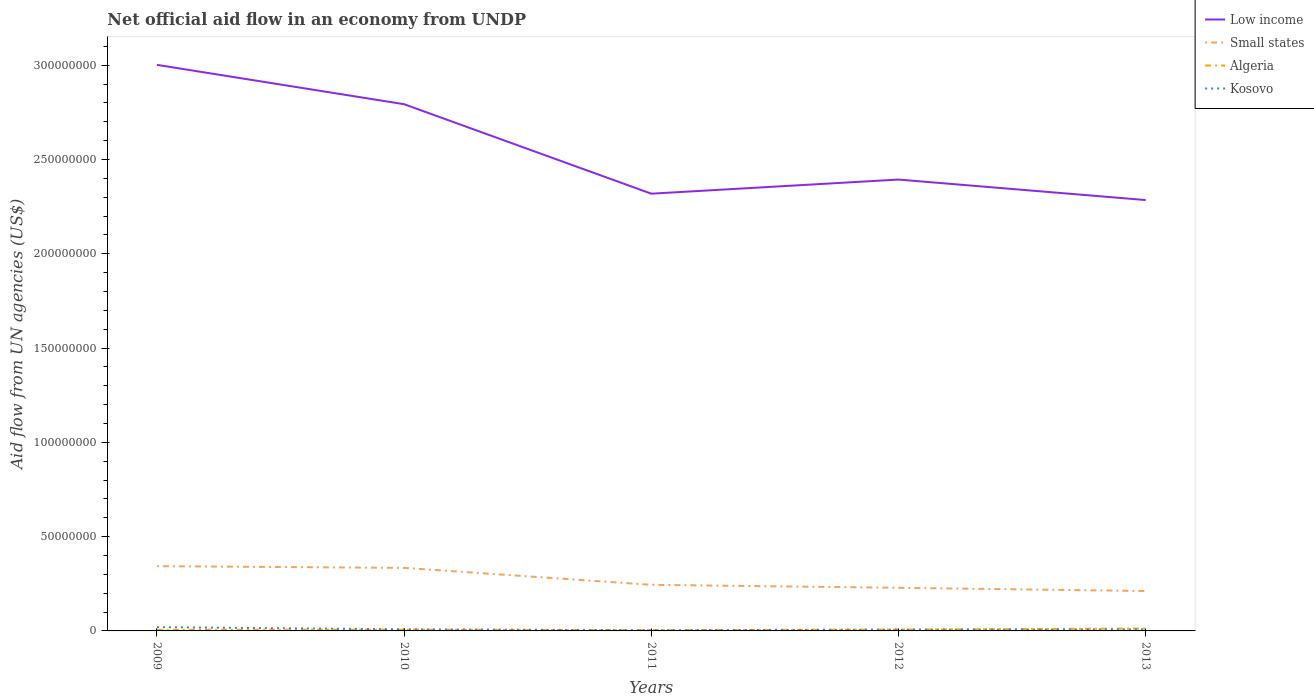Does the line corresponding to Kosovo intersect with the line corresponding to Algeria?
Provide a short and direct response. Yes. Across all years, what is the maximum net official aid flow in Algeria?
Your response must be concise. 4.20e+05. In which year was the net official aid flow in Kosovo maximum?
Offer a very short reply. 2011. What is the total net official aid flow in Algeria in the graph?
Your answer should be compact. -1.40e+05. What is the difference between the highest and the second highest net official aid flow in Algeria?
Provide a succinct answer. 8.40e+05. How many lines are there?
Your answer should be compact. 4. How many years are there in the graph?
Your answer should be compact. 5. Are the values on the major ticks of Y-axis written in scientific E-notation?
Your response must be concise. No. Does the graph contain grids?
Provide a short and direct response. No. How many legend labels are there?
Give a very brief answer. 4. How are the legend labels stacked?
Provide a short and direct response. Vertical. What is the title of the graph?
Your answer should be very brief. Net official aid flow in an economy from UNDP. Does "East Asia (developing only)" appear as one of the legend labels in the graph?
Provide a short and direct response. No. What is the label or title of the X-axis?
Ensure brevity in your answer.  Years. What is the label or title of the Y-axis?
Provide a short and direct response. Aid flow from UN agencies (US$). What is the Aid flow from UN agencies (US$) of Low income in 2009?
Offer a very short reply. 3.00e+08. What is the Aid flow from UN agencies (US$) in Small states in 2009?
Provide a succinct answer. 3.43e+07. What is the Aid flow from UN agencies (US$) of Algeria in 2009?
Give a very brief answer. 5.80e+05. What is the Aid flow from UN agencies (US$) of Kosovo in 2009?
Give a very brief answer. 1.99e+06. What is the Aid flow from UN agencies (US$) of Low income in 2010?
Provide a succinct answer. 2.79e+08. What is the Aid flow from UN agencies (US$) in Small states in 2010?
Keep it short and to the point. 3.34e+07. What is the Aid flow from UN agencies (US$) in Algeria in 2010?
Keep it short and to the point. 6.80e+05. What is the Aid flow from UN agencies (US$) in Kosovo in 2010?
Offer a terse response. 8.50e+05. What is the Aid flow from UN agencies (US$) in Low income in 2011?
Offer a very short reply. 2.32e+08. What is the Aid flow from UN agencies (US$) of Small states in 2011?
Your response must be concise. 2.44e+07. What is the Aid flow from UN agencies (US$) of Algeria in 2011?
Ensure brevity in your answer.  4.20e+05. What is the Aid flow from UN agencies (US$) in Kosovo in 2011?
Make the answer very short. 3.80e+05. What is the Aid flow from UN agencies (US$) in Low income in 2012?
Give a very brief answer. 2.39e+08. What is the Aid flow from UN agencies (US$) of Small states in 2012?
Offer a terse response. 2.29e+07. What is the Aid flow from UN agencies (US$) in Algeria in 2012?
Your answer should be very brief. 7.20e+05. What is the Aid flow from UN agencies (US$) in Kosovo in 2012?
Ensure brevity in your answer.  6.80e+05. What is the Aid flow from UN agencies (US$) in Low income in 2013?
Your response must be concise. 2.28e+08. What is the Aid flow from UN agencies (US$) of Small states in 2013?
Offer a terse response. 2.12e+07. What is the Aid flow from UN agencies (US$) of Algeria in 2013?
Your response must be concise. 1.26e+06. What is the Aid flow from UN agencies (US$) in Kosovo in 2013?
Offer a terse response. 8.30e+05. Across all years, what is the maximum Aid flow from UN agencies (US$) in Low income?
Your response must be concise. 3.00e+08. Across all years, what is the maximum Aid flow from UN agencies (US$) of Small states?
Provide a succinct answer. 3.43e+07. Across all years, what is the maximum Aid flow from UN agencies (US$) of Algeria?
Your response must be concise. 1.26e+06. Across all years, what is the maximum Aid flow from UN agencies (US$) in Kosovo?
Offer a very short reply. 1.99e+06. Across all years, what is the minimum Aid flow from UN agencies (US$) of Low income?
Provide a short and direct response. 2.28e+08. Across all years, what is the minimum Aid flow from UN agencies (US$) of Small states?
Your response must be concise. 2.12e+07. Across all years, what is the minimum Aid flow from UN agencies (US$) of Algeria?
Keep it short and to the point. 4.20e+05. What is the total Aid flow from UN agencies (US$) in Low income in the graph?
Provide a short and direct response. 1.28e+09. What is the total Aid flow from UN agencies (US$) of Small states in the graph?
Offer a terse response. 1.36e+08. What is the total Aid flow from UN agencies (US$) of Algeria in the graph?
Offer a very short reply. 3.66e+06. What is the total Aid flow from UN agencies (US$) in Kosovo in the graph?
Provide a succinct answer. 4.73e+06. What is the difference between the Aid flow from UN agencies (US$) in Low income in 2009 and that in 2010?
Give a very brief answer. 2.09e+07. What is the difference between the Aid flow from UN agencies (US$) in Small states in 2009 and that in 2010?
Provide a succinct answer. 9.10e+05. What is the difference between the Aid flow from UN agencies (US$) in Kosovo in 2009 and that in 2010?
Ensure brevity in your answer.  1.14e+06. What is the difference between the Aid flow from UN agencies (US$) in Low income in 2009 and that in 2011?
Provide a succinct answer. 6.83e+07. What is the difference between the Aid flow from UN agencies (US$) of Small states in 2009 and that in 2011?
Your answer should be very brief. 9.89e+06. What is the difference between the Aid flow from UN agencies (US$) in Kosovo in 2009 and that in 2011?
Give a very brief answer. 1.61e+06. What is the difference between the Aid flow from UN agencies (US$) in Low income in 2009 and that in 2012?
Make the answer very short. 6.08e+07. What is the difference between the Aid flow from UN agencies (US$) in Small states in 2009 and that in 2012?
Make the answer very short. 1.15e+07. What is the difference between the Aid flow from UN agencies (US$) of Algeria in 2009 and that in 2012?
Make the answer very short. -1.40e+05. What is the difference between the Aid flow from UN agencies (US$) of Kosovo in 2009 and that in 2012?
Ensure brevity in your answer.  1.31e+06. What is the difference between the Aid flow from UN agencies (US$) of Low income in 2009 and that in 2013?
Your answer should be compact. 7.17e+07. What is the difference between the Aid flow from UN agencies (US$) in Small states in 2009 and that in 2013?
Offer a very short reply. 1.32e+07. What is the difference between the Aid flow from UN agencies (US$) of Algeria in 2009 and that in 2013?
Offer a very short reply. -6.80e+05. What is the difference between the Aid flow from UN agencies (US$) of Kosovo in 2009 and that in 2013?
Provide a succinct answer. 1.16e+06. What is the difference between the Aid flow from UN agencies (US$) in Low income in 2010 and that in 2011?
Provide a short and direct response. 4.74e+07. What is the difference between the Aid flow from UN agencies (US$) in Small states in 2010 and that in 2011?
Provide a succinct answer. 8.98e+06. What is the difference between the Aid flow from UN agencies (US$) in Low income in 2010 and that in 2012?
Offer a terse response. 4.00e+07. What is the difference between the Aid flow from UN agencies (US$) of Small states in 2010 and that in 2012?
Give a very brief answer. 1.06e+07. What is the difference between the Aid flow from UN agencies (US$) of Kosovo in 2010 and that in 2012?
Keep it short and to the point. 1.70e+05. What is the difference between the Aid flow from UN agencies (US$) in Low income in 2010 and that in 2013?
Your response must be concise. 5.08e+07. What is the difference between the Aid flow from UN agencies (US$) of Small states in 2010 and that in 2013?
Offer a very short reply. 1.23e+07. What is the difference between the Aid flow from UN agencies (US$) in Algeria in 2010 and that in 2013?
Offer a very short reply. -5.80e+05. What is the difference between the Aid flow from UN agencies (US$) of Kosovo in 2010 and that in 2013?
Offer a terse response. 2.00e+04. What is the difference between the Aid flow from UN agencies (US$) of Low income in 2011 and that in 2012?
Keep it short and to the point. -7.49e+06. What is the difference between the Aid flow from UN agencies (US$) of Small states in 2011 and that in 2012?
Your response must be concise. 1.58e+06. What is the difference between the Aid flow from UN agencies (US$) in Low income in 2011 and that in 2013?
Give a very brief answer. 3.38e+06. What is the difference between the Aid flow from UN agencies (US$) in Small states in 2011 and that in 2013?
Provide a short and direct response. 3.29e+06. What is the difference between the Aid flow from UN agencies (US$) in Algeria in 2011 and that in 2013?
Keep it short and to the point. -8.40e+05. What is the difference between the Aid flow from UN agencies (US$) of Kosovo in 2011 and that in 2013?
Ensure brevity in your answer.  -4.50e+05. What is the difference between the Aid flow from UN agencies (US$) in Low income in 2012 and that in 2013?
Your answer should be compact. 1.09e+07. What is the difference between the Aid flow from UN agencies (US$) of Small states in 2012 and that in 2013?
Offer a very short reply. 1.71e+06. What is the difference between the Aid flow from UN agencies (US$) in Algeria in 2012 and that in 2013?
Your answer should be very brief. -5.40e+05. What is the difference between the Aid flow from UN agencies (US$) in Kosovo in 2012 and that in 2013?
Ensure brevity in your answer.  -1.50e+05. What is the difference between the Aid flow from UN agencies (US$) in Low income in 2009 and the Aid flow from UN agencies (US$) in Small states in 2010?
Offer a very short reply. 2.67e+08. What is the difference between the Aid flow from UN agencies (US$) in Low income in 2009 and the Aid flow from UN agencies (US$) in Algeria in 2010?
Provide a succinct answer. 3.00e+08. What is the difference between the Aid flow from UN agencies (US$) of Low income in 2009 and the Aid flow from UN agencies (US$) of Kosovo in 2010?
Your answer should be compact. 2.99e+08. What is the difference between the Aid flow from UN agencies (US$) of Small states in 2009 and the Aid flow from UN agencies (US$) of Algeria in 2010?
Give a very brief answer. 3.37e+07. What is the difference between the Aid flow from UN agencies (US$) of Small states in 2009 and the Aid flow from UN agencies (US$) of Kosovo in 2010?
Offer a terse response. 3.35e+07. What is the difference between the Aid flow from UN agencies (US$) of Low income in 2009 and the Aid flow from UN agencies (US$) of Small states in 2011?
Ensure brevity in your answer.  2.76e+08. What is the difference between the Aid flow from UN agencies (US$) in Low income in 2009 and the Aid flow from UN agencies (US$) in Algeria in 2011?
Offer a terse response. 3.00e+08. What is the difference between the Aid flow from UN agencies (US$) in Low income in 2009 and the Aid flow from UN agencies (US$) in Kosovo in 2011?
Ensure brevity in your answer.  3.00e+08. What is the difference between the Aid flow from UN agencies (US$) in Small states in 2009 and the Aid flow from UN agencies (US$) in Algeria in 2011?
Ensure brevity in your answer.  3.39e+07. What is the difference between the Aid flow from UN agencies (US$) of Small states in 2009 and the Aid flow from UN agencies (US$) of Kosovo in 2011?
Your response must be concise. 3.40e+07. What is the difference between the Aid flow from UN agencies (US$) of Low income in 2009 and the Aid flow from UN agencies (US$) of Small states in 2012?
Your answer should be very brief. 2.77e+08. What is the difference between the Aid flow from UN agencies (US$) of Low income in 2009 and the Aid flow from UN agencies (US$) of Algeria in 2012?
Keep it short and to the point. 2.99e+08. What is the difference between the Aid flow from UN agencies (US$) in Low income in 2009 and the Aid flow from UN agencies (US$) in Kosovo in 2012?
Offer a terse response. 3.00e+08. What is the difference between the Aid flow from UN agencies (US$) in Small states in 2009 and the Aid flow from UN agencies (US$) in Algeria in 2012?
Provide a succinct answer. 3.36e+07. What is the difference between the Aid flow from UN agencies (US$) of Small states in 2009 and the Aid flow from UN agencies (US$) of Kosovo in 2012?
Provide a short and direct response. 3.37e+07. What is the difference between the Aid flow from UN agencies (US$) in Algeria in 2009 and the Aid flow from UN agencies (US$) in Kosovo in 2012?
Offer a terse response. -1.00e+05. What is the difference between the Aid flow from UN agencies (US$) in Low income in 2009 and the Aid flow from UN agencies (US$) in Small states in 2013?
Offer a terse response. 2.79e+08. What is the difference between the Aid flow from UN agencies (US$) in Low income in 2009 and the Aid flow from UN agencies (US$) in Algeria in 2013?
Provide a short and direct response. 2.99e+08. What is the difference between the Aid flow from UN agencies (US$) in Low income in 2009 and the Aid flow from UN agencies (US$) in Kosovo in 2013?
Provide a short and direct response. 2.99e+08. What is the difference between the Aid flow from UN agencies (US$) of Small states in 2009 and the Aid flow from UN agencies (US$) of Algeria in 2013?
Ensure brevity in your answer.  3.31e+07. What is the difference between the Aid flow from UN agencies (US$) in Small states in 2009 and the Aid flow from UN agencies (US$) in Kosovo in 2013?
Provide a succinct answer. 3.35e+07. What is the difference between the Aid flow from UN agencies (US$) in Low income in 2010 and the Aid flow from UN agencies (US$) in Small states in 2011?
Keep it short and to the point. 2.55e+08. What is the difference between the Aid flow from UN agencies (US$) in Low income in 2010 and the Aid flow from UN agencies (US$) in Algeria in 2011?
Keep it short and to the point. 2.79e+08. What is the difference between the Aid flow from UN agencies (US$) of Low income in 2010 and the Aid flow from UN agencies (US$) of Kosovo in 2011?
Your response must be concise. 2.79e+08. What is the difference between the Aid flow from UN agencies (US$) of Small states in 2010 and the Aid flow from UN agencies (US$) of Algeria in 2011?
Give a very brief answer. 3.30e+07. What is the difference between the Aid flow from UN agencies (US$) of Small states in 2010 and the Aid flow from UN agencies (US$) of Kosovo in 2011?
Your response must be concise. 3.30e+07. What is the difference between the Aid flow from UN agencies (US$) of Low income in 2010 and the Aid flow from UN agencies (US$) of Small states in 2012?
Keep it short and to the point. 2.56e+08. What is the difference between the Aid flow from UN agencies (US$) of Low income in 2010 and the Aid flow from UN agencies (US$) of Algeria in 2012?
Provide a short and direct response. 2.79e+08. What is the difference between the Aid flow from UN agencies (US$) in Low income in 2010 and the Aid flow from UN agencies (US$) in Kosovo in 2012?
Keep it short and to the point. 2.79e+08. What is the difference between the Aid flow from UN agencies (US$) in Small states in 2010 and the Aid flow from UN agencies (US$) in Algeria in 2012?
Your response must be concise. 3.27e+07. What is the difference between the Aid flow from UN agencies (US$) in Small states in 2010 and the Aid flow from UN agencies (US$) in Kosovo in 2012?
Provide a short and direct response. 3.28e+07. What is the difference between the Aid flow from UN agencies (US$) in Low income in 2010 and the Aid flow from UN agencies (US$) in Small states in 2013?
Give a very brief answer. 2.58e+08. What is the difference between the Aid flow from UN agencies (US$) in Low income in 2010 and the Aid flow from UN agencies (US$) in Algeria in 2013?
Offer a terse response. 2.78e+08. What is the difference between the Aid flow from UN agencies (US$) of Low income in 2010 and the Aid flow from UN agencies (US$) of Kosovo in 2013?
Your answer should be very brief. 2.78e+08. What is the difference between the Aid flow from UN agencies (US$) in Small states in 2010 and the Aid flow from UN agencies (US$) in Algeria in 2013?
Your answer should be very brief. 3.22e+07. What is the difference between the Aid flow from UN agencies (US$) in Small states in 2010 and the Aid flow from UN agencies (US$) in Kosovo in 2013?
Offer a terse response. 3.26e+07. What is the difference between the Aid flow from UN agencies (US$) of Low income in 2011 and the Aid flow from UN agencies (US$) of Small states in 2012?
Give a very brief answer. 2.09e+08. What is the difference between the Aid flow from UN agencies (US$) of Low income in 2011 and the Aid flow from UN agencies (US$) of Algeria in 2012?
Provide a short and direct response. 2.31e+08. What is the difference between the Aid flow from UN agencies (US$) of Low income in 2011 and the Aid flow from UN agencies (US$) of Kosovo in 2012?
Ensure brevity in your answer.  2.31e+08. What is the difference between the Aid flow from UN agencies (US$) in Small states in 2011 and the Aid flow from UN agencies (US$) in Algeria in 2012?
Give a very brief answer. 2.37e+07. What is the difference between the Aid flow from UN agencies (US$) of Small states in 2011 and the Aid flow from UN agencies (US$) of Kosovo in 2012?
Offer a terse response. 2.38e+07. What is the difference between the Aid flow from UN agencies (US$) in Low income in 2011 and the Aid flow from UN agencies (US$) in Small states in 2013?
Your response must be concise. 2.11e+08. What is the difference between the Aid flow from UN agencies (US$) in Low income in 2011 and the Aid flow from UN agencies (US$) in Algeria in 2013?
Your answer should be very brief. 2.31e+08. What is the difference between the Aid flow from UN agencies (US$) of Low income in 2011 and the Aid flow from UN agencies (US$) of Kosovo in 2013?
Offer a terse response. 2.31e+08. What is the difference between the Aid flow from UN agencies (US$) in Small states in 2011 and the Aid flow from UN agencies (US$) in Algeria in 2013?
Your answer should be compact. 2.32e+07. What is the difference between the Aid flow from UN agencies (US$) of Small states in 2011 and the Aid flow from UN agencies (US$) of Kosovo in 2013?
Offer a very short reply. 2.36e+07. What is the difference between the Aid flow from UN agencies (US$) in Algeria in 2011 and the Aid flow from UN agencies (US$) in Kosovo in 2013?
Your response must be concise. -4.10e+05. What is the difference between the Aid flow from UN agencies (US$) in Low income in 2012 and the Aid flow from UN agencies (US$) in Small states in 2013?
Give a very brief answer. 2.18e+08. What is the difference between the Aid flow from UN agencies (US$) of Low income in 2012 and the Aid flow from UN agencies (US$) of Algeria in 2013?
Your answer should be very brief. 2.38e+08. What is the difference between the Aid flow from UN agencies (US$) of Low income in 2012 and the Aid flow from UN agencies (US$) of Kosovo in 2013?
Provide a succinct answer. 2.39e+08. What is the difference between the Aid flow from UN agencies (US$) in Small states in 2012 and the Aid flow from UN agencies (US$) in Algeria in 2013?
Offer a very short reply. 2.16e+07. What is the difference between the Aid flow from UN agencies (US$) in Small states in 2012 and the Aid flow from UN agencies (US$) in Kosovo in 2013?
Offer a terse response. 2.20e+07. What is the difference between the Aid flow from UN agencies (US$) in Algeria in 2012 and the Aid flow from UN agencies (US$) in Kosovo in 2013?
Ensure brevity in your answer.  -1.10e+05. What is the average Aid flow from UN agencies (US$) in Low income per year?
Give a very brief answer. 2.56e+08. What is the average Aid flow from UN agencies (US$) in Small states per year?
Your answer should be very brief. 2.72e+07. What is the average Aid flow from UN agencies (US$) in Algeria per year?
Provide a short and direct response. 7.32e+05. What is the average Aid flow from UN agencies (US$) of Kosovo per year?
Provide a succinct answer. 9.46e+05. In the year 2009, what is the difference between the Aid flow from UN agencies (US$) of Low income and Aid flow from UN agencies (US$) of Small states?
Keep it short and to the point. 2.66e+08. In the year 2009, what is the difference between the Aid flow from UN agencies (US$) in Low income and Aid flow from UN agencies (US$) in Algeria?
Your answer should be very brief. 3.00e+08. In the year 2009, what is the difference between the Aid flow from UN agencies (US$) in Low income and Aid flow from UN agencies (US$) in Kosovo?
Give a very brief answer. 2.98e+08. In the year 2009, what is the difference between the Aid flow from UN agencies (US$) in Small states and Aid flow from UN agencies (US$) in Algeria?
Give a very brief answer. 3.38e+07. In the year 2009, what is the difference between the Aid flow from UN agencies (US$) in Small states and Aid flow from UN agencies (US$) in Kosovo?
Offer a very short reply. 3.24e+07. In the year 2009, what is the difference between the Aid flow from UN agencies (US$) in Algeria and Aid flow from UN agencies (US$) in Kosovo?
Provide a short and direct response. -1.41e+06. In the year 2010, what is the difference between the Aid flow from UN agencies (US$) in Low income and Aid flow from UN agencies (US$) in Small states?
Your answer should be very brief. 2.46e+08. In the year 2010, what is the difference between the Aid flow from UN agencies (US$) in Low income and Aid flow from UN agencies (US$) in Algeria?
Keep it short and to the point. 2.79e+08. In the year 2010, what is the difference between the Aid flow from UN agencies (US$) of Low income and Aid flow from UN agencies (US$) of Kosovo?
Provide a succinct answer. 2.78e+08. In the year 2010, what is the difference between the Aid flow from UN agencies (US$) in Small states and Aid flow from UN agencies (US$) in Algeria?
Offer a very short reply. 3.28e+07. In the year 2010, what is the difference between the Aid flow from UN agencies (US$) in Small states and Aid flow from UN agencies (US$) in Kosovo?
Give a very brief answer. 3.26e+07. In the year 2010, what is the difference between the Aid flow from UN agencies (US$) of Algeria and Aid flow from UN agencies (US$) of Kosovo?
Ensure brevity in your answer.  -1.70e+05. In the year 2011, what is the difference between the Aid flow from UN agencies (US$) of Low income and Aid flow from UN agencies (US$) of Small states?
Offer a very short reply. 2.07e+08. In the year 2011, what is the difference between the Aid flow from UN agencies (US$) in Low income and Aid flow from UN agencies (US$) in Algeria?
Provide a succinct answer. 2.31e+08. In the year 2011, what is the difference between the Aid flow from UN agencies (US$) of Low income and Aid flow from UN agencies (US$) of Kosovo?
Keep it short and to the point. 2.31e+08. In the year 2011, what is the difference between the Aid flow from UN agencies (US$) in Small states and Aid flow from UN agencies (US$) in Algeria?
Make the answer very short. 2.40e+07. In the year 2011, what is the difference between the Aid flow from UN agencies (US$) in Small states and Aid flow from UN agencies (US$) in Kosovo?
Provide a short and direct response. 2.41e+07. In the year 2011, what is the difference between the Aid flow from UN agencies (US$) in Algeria and Aid flow from UN agencies (US$) in Kosovo?
Keep it short and to the point. 4.00e+04. In the year 2012, what is the difference between the Aid flow from UN agencies (US$) in Low income and Aid flow from UN agencies (US$) in Small states?
Keep it short and to the point. 2.16e+08. In the year 2012, what is the difference between the Aid flow from UN agencies (US$) in Low income and Aid flow from UN agencies (US$) in Algeria?
Provide a succinct answer. 2.39e+08. In the year 2012, what is the difference between the Aid flow from UN agencies (US$) in Low income and Aid flow from UN agencies (US$) in Kosovo?
Provide a succinct answer. 2.39e+08. In the year 2012, what is the difference between the Aid flow from UN agencies (US$) of Small states and Aid flow from UN agencies (US$) of Algeria?
Offer a very short reply. 2.22e+07. In the year 2012, what is the difference between the Aid flow from UN agencies (US$) in Small states and Aid flow from UN agencies (US$) in Kosovo?
Your response must be concise. 2.22e+07. In the year 2013, what is the difference between the Aid flow from UN agencies (US$) in Low income and Aid flow from UN agencies (US$) in Small states?
Offer a very short reply. 2.07e+08. In the year 2013, what is the difference between the Aid flow from UN agencies (US$) of Low income and Aid flow from UN agencies (US$) of Algeria?
Keep it short and to the point. 2.27e+08. In the year 2013, what is the difference between the Aid flow from UN agencies (US$) of Low income and Aid flow from UN agencies (US$) of Kosovo?
Your response must be concise. 2.28e+08. In the year 2013, what is the difference between the Aid flow from UN agencies (US$) of Small states and Aid flow from UN agencies (US$) of Algeria?
Ensure brevity in your answer.  1.99e+07. In the year 2013, what is the difference between the Aid flow from UN agencies (US$) in Small states and Aid flow from UN agencies (US$) in Kosovo?
Provide a short and direct response. 2.03e+07. What is the ratio of the Aid flow from UN agencies (US$) in Low income in 2009 to that in 2010?
Offer a very short reply. 1.07. What is the ratio of the Aid flow from UN agencies (US$) of Small states in 2009 to that in 2010?
Offer a terse response. 1.03. What is the ratio of the Aid flow from UN agencies (US$) in Algeria in 2009 to that in 2010?
Offer a terse response. 0.85. What is the ratio of the Aid flow from UN agencies (US$) of Kosovo in 2009 to that in 2010?
Keep it short and to the point. 2.34. What is the ratio of the Aid flow from UN agencies (US$) of Low income in 2009 to that in 2011?
Keep it short and to the point. 1.29. What is the ratio of the Aid flow from UN agencies (US$) in Small states in 2009 to that in 2011?
Make the answer very short. 1.4. What is the ratio of the Aid flow from UN agencies (US$) in Algeria in 2009 to that in 2011?
Your answer should be compact. 1.38. What is the ratio of the Aid flow from UN agencies (US$) of Kosovo in 2009 to that in 2011?
Offer a terse response. 5.24. What is the ratio of the Aid flow from UN agencies (US$) of Low income in 2009 to that in 2012?
Ensure brevity in your answer.  1.25. What is the ratio of the Aid flow from UN agencies (US$) of Small states in 2009 to that in 2012?
Your response must be concise. 1.5. What is the ratio of the Aid flow from UN agencies (US$) in Algeria in 2009 to that in 2012?
Keep it short and to the point. 0.81. What is the ratio of the Aid flow from UN agencies (US$) of Kosovo in 2009 to that in 2012?
Offer a very short reply. 2.93. What is the ratio of the Aid flow from UN agencies (US$) in Low income in 2009 to that in 2013?
Keep it short and to the point. 1.31. What is the ratio of the Aid flow from UN agencies (US$) of Small states in 2009 to that in 2013?
Provide a short and direct response. 1.62. What is the ratio of the Aid flow from UN agencies (US$) of Algeria in 2009 to that in 2013?
Keep it short and to the point. 0.46. What is the ratio of the Aid flow from UN agencies (US$) of Kosovo in 2009 to that in 2013?
Make the answer very short. 2.4. What is the ratio of the Aid flow from UN agencies (US$) in Low income in 2010 to that in 2011?
Offer a very short reply. 1.2. What is the ratio of the Aid flow from UN agencies (US$) in Small states in 2010 to that in 2011?
Make the answer very short. 1.37. What is the ratio of the Aid flow from UN agencies (US$) of Algeria in 2010 to that in 2011?
Your answer should be very brief. 1.62. What is the ratio of the Aid flow from UN agencies (US$) in Kosovo in 2010 to that in 2011?
Ensure brevity in your answer.  2.24. What is the ratio of the Aid flow from UN agencies (US$) in Low income in 2010 to that in 2012?
Provide a succinct answer. 1.17. What is the ratio of the Aid flow from UN agencies (US$) in Small states in 2010 to that in 2012?
Ensure brevity in your answer.  1.46. What is the ratio of the Aid flow from UN agencies (US$) in Low income in 2010 to that in 2013?
Your answer should be very brief. 1.22. What is the ratio of the Aid flow from UN agencies (US$) in Small states in 2010 to that in 2013?
Offer a very short reply. 1.58. What is the ratio of the Aid flow from UN agencies (US$) of Algeria in 2010 to that in 2013?
Ensure brevity in your answer.  0.54. What is the ratio of the Aid flow from UN agencies (US$) of Kosovo in 2010 to that in 2013?
Provide a short and direct response. 1.02. What is the ratio of the Aid flow from UN agencies (US$) in Low income in 2011 to that in 2012?
Offer a very short reply. 0.97. What is the ratio of the Aid flow from UN agencies (US$) of Small states in 2011 to that in 2012?
Provide a succinct answer. 1.07. What is the ratio of the Aid flow from UN agencies (US$) in Algeria in 2011 to that in 2012?
Offer a terse response. 0.58. What is the ratio of the Aid flow from UN agencies (US$) in Kosovo in 2011 to that in 2012?
Offer a very short reply. 0.56. What is the ratio of the Aid flow from UN agencies (US$) in Low income in 2011 to that in 2013?
Offer a terse response. 1.01. What is the ratio of the Aid flow from UN agencies (US$) of Small states in 2011 to that in 2013?
Your response must be concise. 1.16. What is the ratio of the Aid flow from UN agencies (US$) of Algeria in 2011 to that in 2013?
Offer a very short reply. 0.33. What is the ratio of the Aid flow from UN agencies (US$) in Kosovo in 2011 to that in 2013?
Ensure brevity in your answer.  0.46. What is the ratio of the Aid flow from UN agencies (US$) in Low income in 2012 to that in 2013?
Ensure brevity in your answer.  1.05. What is the ratio of the Aid flow from UN agencies (US$) of Small states in 2012 to that in 2013?
Provide a succinct answer. 1.08. What is the ratio of the Aid flow from UN agencies (US$) in Kosovo in 2012 to that in 2013?
Give a very brief answer. 0.82. What is the difference between the highest and the second highest Aid flow from UN agencies (US$) in Low income?
Provide a short and direct response. 2.09e+07. What is the difference between the highest and the second highest Aid flow from UN agencies (US$) of Small states?
Keep it short and to the point. 9.10e+05. What is the difference between the highest and the second highest Aid flow from UN agencies (US$) of Algeria?
Your answer should be very brief. 5.40e+05. What is the difference between the highest and the second highest Aid flow from UN agencies (US$) in Kosovo?
Make the answer very short. 1.14e+06. What is the difference between the highest and the lowest Aid flow from UN agencies (US$) in Low income?
Ensure brevity in your answer.  7.17e+07. What is the difference between the highest and the lowest Aid flow from UN agencies (US$) of Small states?
Ensure brevity in your answer.  1.32e+07. What is the difference between the highest and the lowest Aid flow from UN agencies (US$) in Algeria?
Make the answer very short. 8.40e+05. What is the difference between the highest and the lowest Aid flow from UN agencies (US$) of Kosovo?
Offer a very short reply. 1.61e+06. 